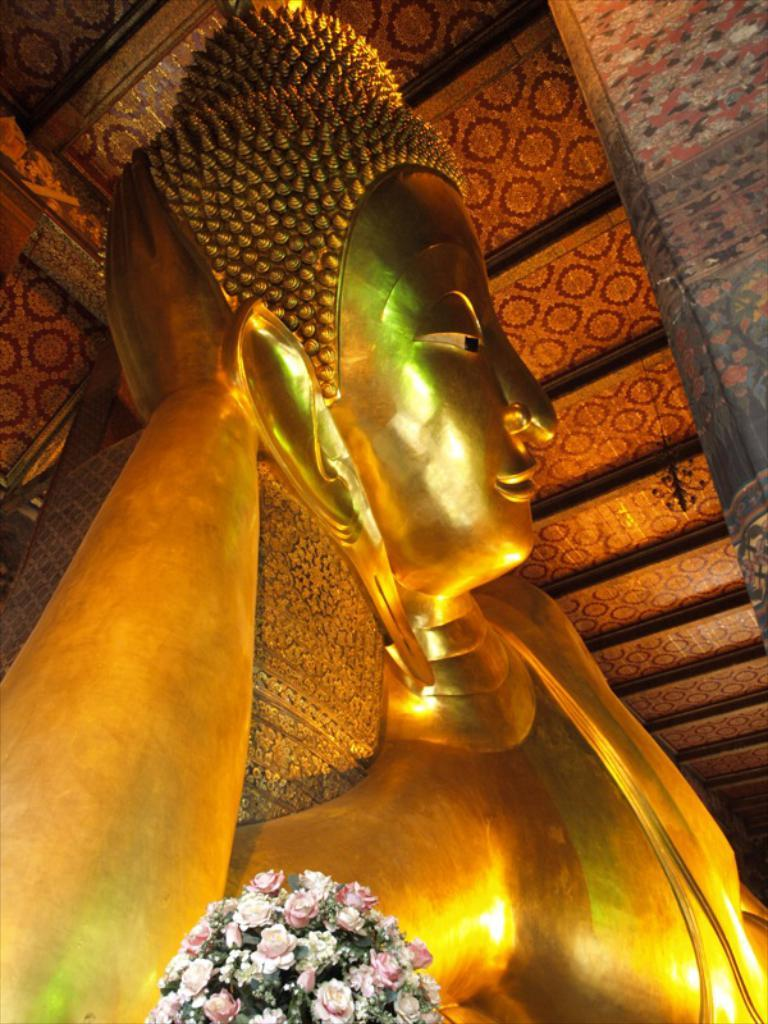What type of objects can be seen in the image? There are statues and flowers in the image. Can you describe the statues in the image? Unfortunately, the provided facts do not give any details about the statues. What type of flowers are present in the image? The provided facts do not specify the type of flowers in the image. What color is the balloon that is tied to the statue in the image? There is no balloon present in the image. What reward is given to the person who can correctly identify the smile on the statue in the image? There is no mention of a reward or a smile on the statue in the provided facts. 